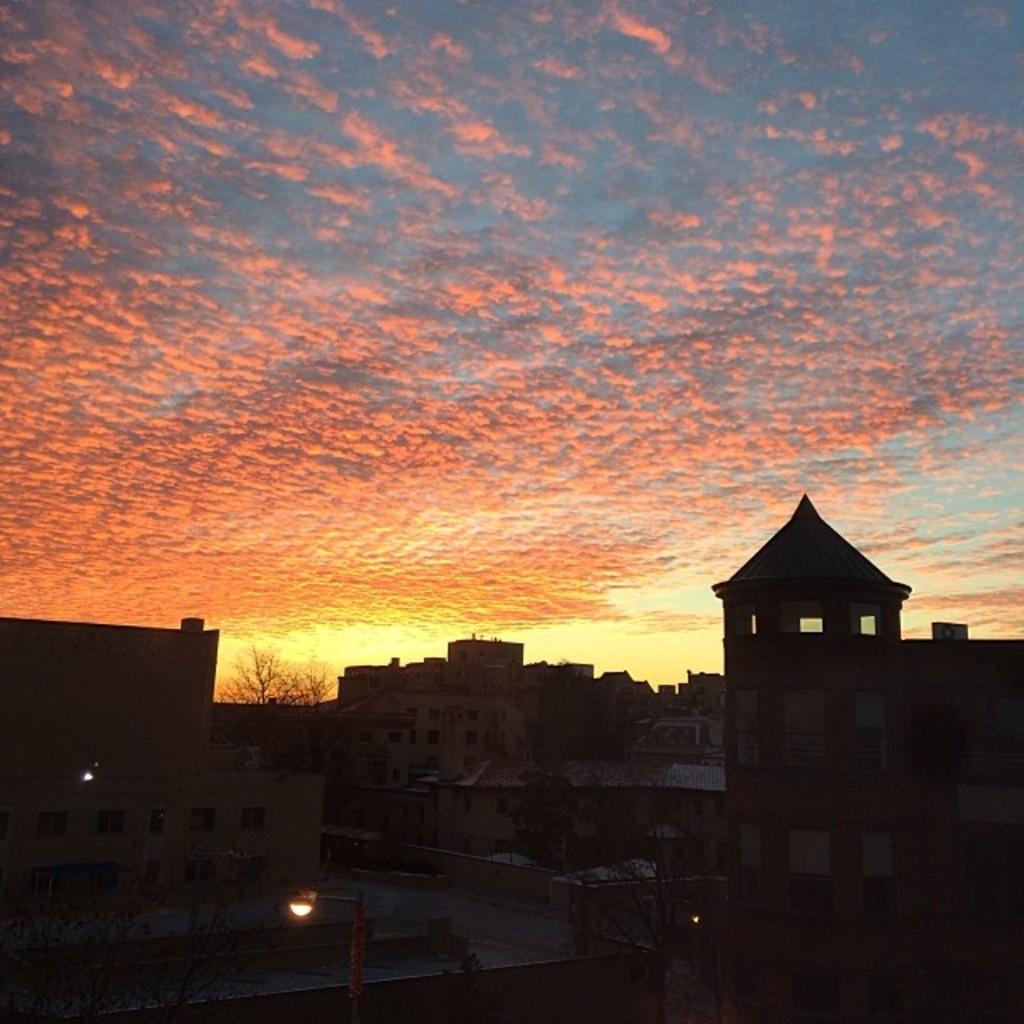Could you give a brief overview of what you see in this image? This picture is taken from outside of the city. In this image, we can see some buildings, street lights, houses, trees. At the top, we can see a sky which is a bit cloudy and the sky is in orange and color, at the bottom, we can see black color. 